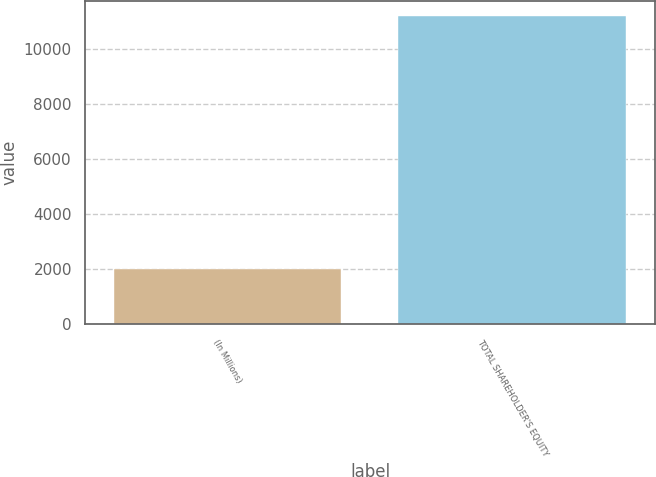Convert chart. <chart><loc_0><loc_0><loc_500><loc_500><bar_chart><fcel>(In Millions)<fcel>TOTAL SHAREHOLDER'S EQUITY<nl><fcel>2014<fcel>11199<nl></chart> 